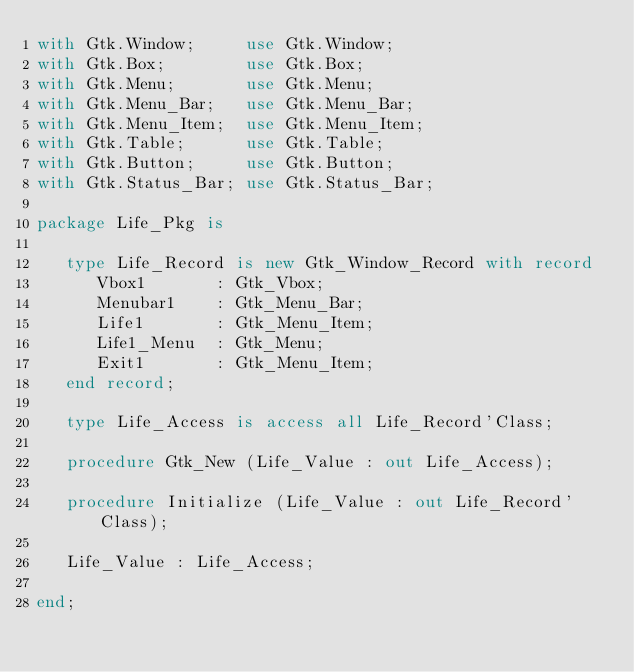<code> <loc_0><loc_0><loc_500><loc_500><_Ada_>with Gtk.Window;     use Gtk.Window;
with Gtk.Box;        use Gtk.Box;
with Gtk.Menu;       use Gtk.Menu;
with Gtk.Menu_Bar;   use Gtk.Menu_Bar;
with Gtk.Menu_Item;  use Gtk.Menu_Item;
with Gtk.Table;      use Gtk.Table;
with Gtk.Button;     use Gtk.Button;
with Gtk.Status_Bar; use Gtk.Status_Bar;

package Life_Pkg is

   type Life_Record is new Gtk_Window_Record with record
      Vbox1       : Gtk_Vbox;
      Menubar1    : Gtk_Menu_Bar;
      Life1       : Gtk_Menu_Item;
      Life1_Menu  : Gtk_Menu;
      Exit1       : Gtk_Menu_Item;
   end record;

   type Life_Access is access all Life_Record'Class;

   procedure Gtk_New (Life_Value : out Life_Access);

   procedure Initialize (Life_Value : out Life_Record'Class);

   Life_Value : Life_Access;

end;
</code> 